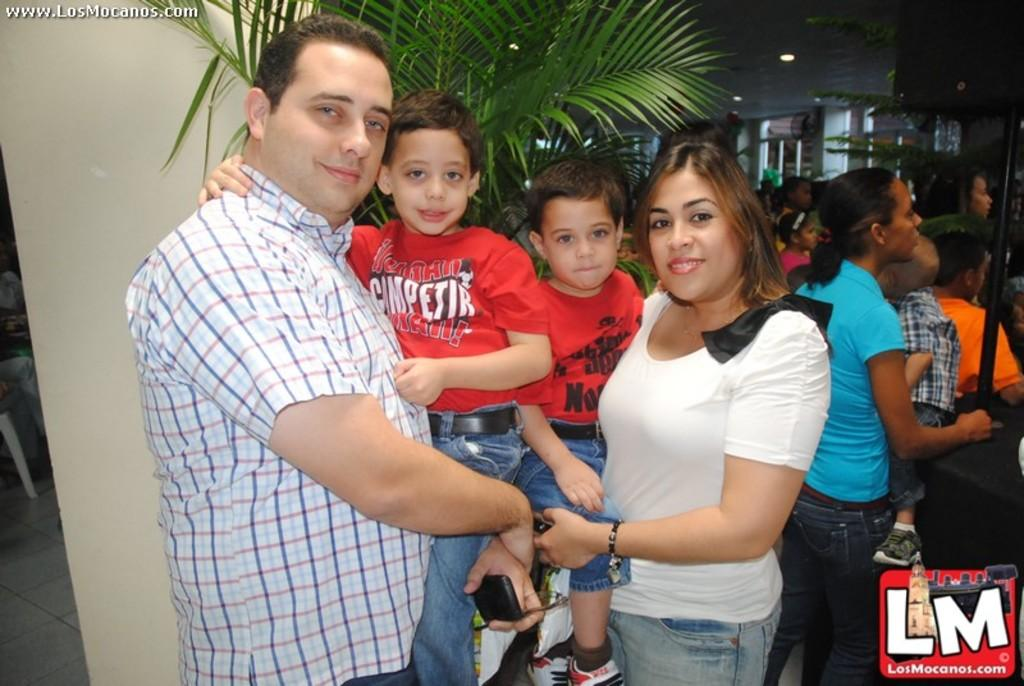What are the people in the foreground of the image doing? The people in the foreground of the image are posing for a photo. Can you describe the other people visible in the image? There are other people visible in the image, but their actions are not specified. What type of vegetation is present in the image? There are plants in the image. What letters can be seen on the plants in the image? There are no letters visible on the plants in the image. 